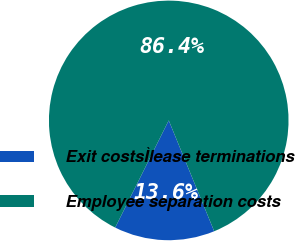Convert chart. <chart><loc_0><loc_0><loc_500><loc_500><pie_chart><fcel>Exit costsÌlease terminations<fcel>Employee separation costs<nl><fcel>13.57%<fcel>86.43%<nl></chart> 